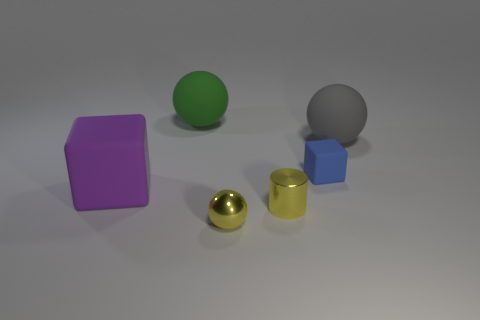Subtract all matte balls. How many balls are left? 1 Subtract all blue blocks. How many blocks are left? 1 Subtract 2 balls. How many balls are left? 1 Add 1 cyan rubber balls. How many objects exist? 7 Subtract all cylinders. How many objects are left? 5 Subtract all gray cubes. How many yellow balls are left? 1 Subtract all yellow spheres. Subtract all cyan cylinders. How many spheres are left? 2 Subtract all small blue cubes. Subtract all tiny yellow metallic things. How many objects are left? 3 Add 1 gray balls. How many gray balls are left? 2 Add 2 large yellow rubber cylinders. How many large yellow rubber cylinders exist? 2 